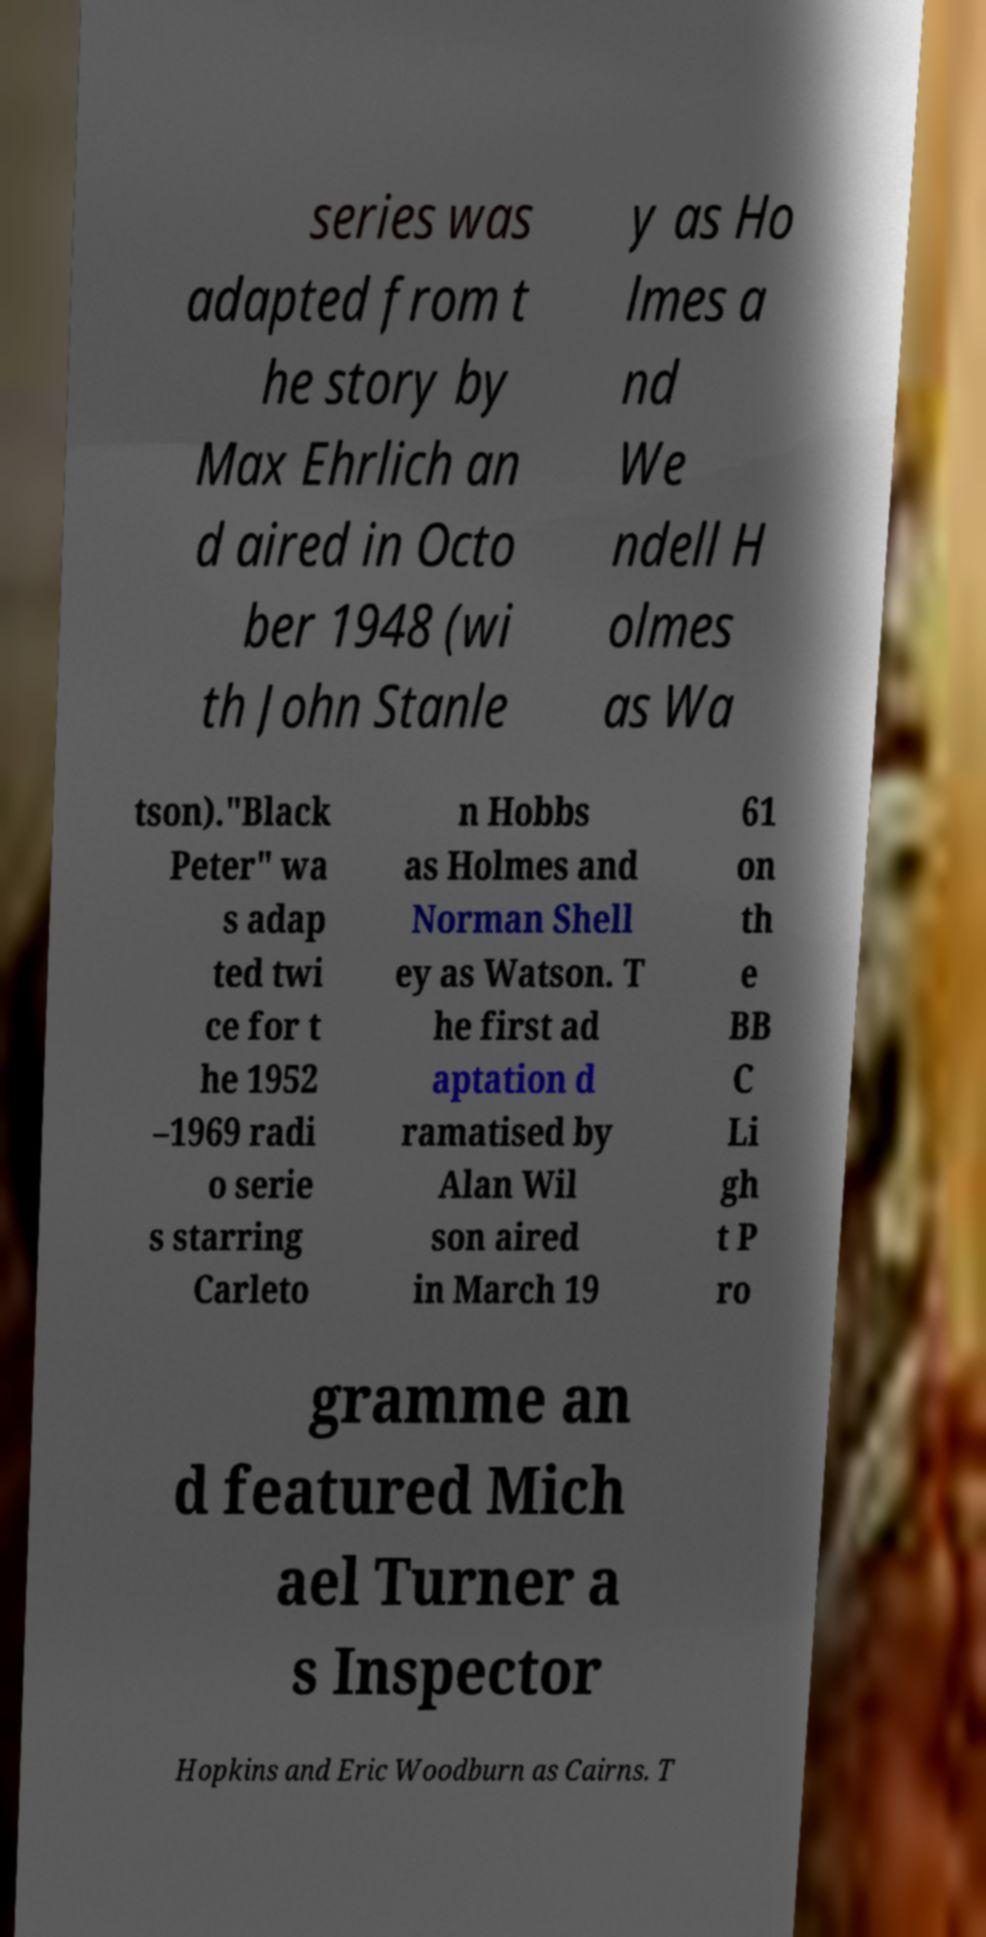Could you assist in decoding the text presented in this image and type it out clearly? series was adapted from t he story by Max Ehrlich an d aired in Octo ber 1948 (wi th John Stanle y as Ho lmes a nd We ndell H olmes as Wa tson)."Black Peter" wa s adap ted twi ce for t he 1952 –1969 radi o serie s starring Carleto n Hobbs as Holmes and Norman Shell ey as Watson. T he first ad aptation d ramatised by Alan Wil son aired in March 19 61 on th e BB C Li gh t P ro gramme an d featured Mich ael Turner a s Inspector Hopkins and Eric Woodburn as Cairns. T 